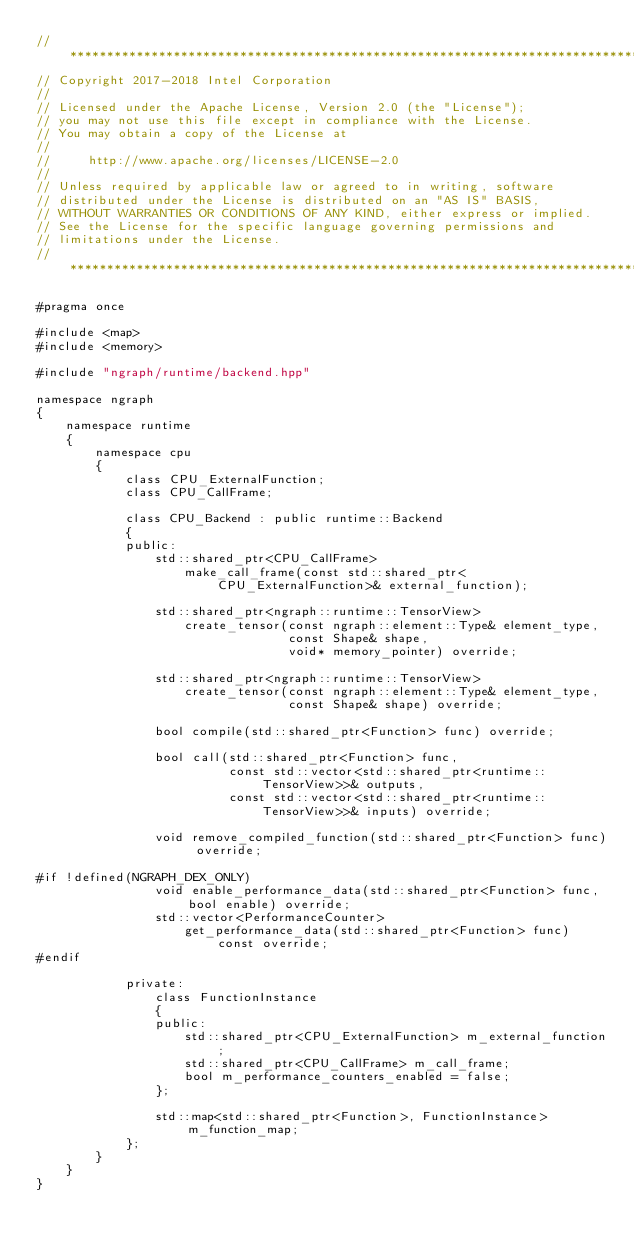<code> <loc_0><loc_0><loc_500><loc_500><_C++_>//*****************************************************************************
// Copyright 2017-2018 Intel Corporation
//
// Licensed under the Apache License, Version 2.0 (the "License");
// you may not use this file except in compliance with the License.
// You may obtain a copy of the License at
//
//     http://www.apache.org/licenses/LICENSE-2.0
//
// Unless required by applicable law or agreed to in writing, software
// distributed under the License is distributed on an "AS IS" BASIS,
// WITHOUT WARRANTIES OR CONDITIONS OF ANY KIND, either express or implied.
// See the License for the specific language governing permissions and
// limitations under the License.
//*****************************************************************************

#pragma once

#include <map>
#include <memory>

#include "ngraph/runtime/backend.hpp"

namespace ngraph
{
    namespace runtime
    {
        namespace cpu
        {
            class CPU_ExternalFunction;
            class CPU_CallFrame;

            class CPU_Backend : public runtime::Backend
            {
            public:
                std::shared_ptr<CPU_CallFrame>
                    make_call_frame(const std::shared_ptr<CPU_ExternalFunction>& external_function);

                std::shared_ptr<ngraph::runtime::TensorView>
                    create_tensor(const ngraph::element::Type& element_type,
                                  const Shape& shape,
                                  void* memory_pointer) override;

                std::shared_ptr<ngraph::runtime::TensorView>
                    create_tensor(const ngraph::element::Type& element_type,
                                  const Shape& shape) override;

                bool compile(std::shared_ptr<Function> func) override;

                bool call(std::shared_ptr<Function> func,
                          const std::vector<std::shared_ptr<runtime::TensorView>>& outputs,
                          const std::vector<std::shared_ptr<runtime::TensorView>>& inputs) override;

                void remove_compiled_function(std::shared_ptr<Function> func) override;

#if !defined(NGRAPH_DEX_ONLY)
                void enable_performance_data(std::shared_ptr<Function> func, bool enable) override;
                std::vector<PerformanceCounter>
                    get_performance_data(std::shared_ptr<Function> func) const override;
#endif

            private:
                class FunctionInstance
                {
                public:
                    std::shared_ptr<CPU_ExternalFunction> m_external_function;
                    std::shared_ptr<CPU_CallFrame> m_call_frame;
                    bool m_performance_counters_enabled = false;
                };

                std::map<std::shared_ptr<Function>, FunctionInstance> m_function_map;
            };
        }
    }
}
</code> 